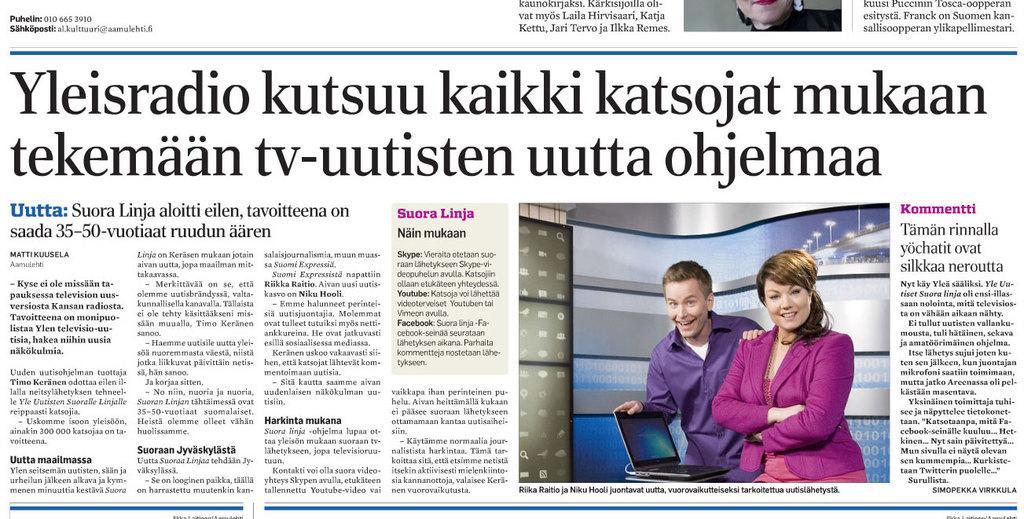Please provide a concise description of this image. I can see the picture of the newspaper. These are the letters. Here is the man and the woman standing and smiling. This is a laptop on the table. 